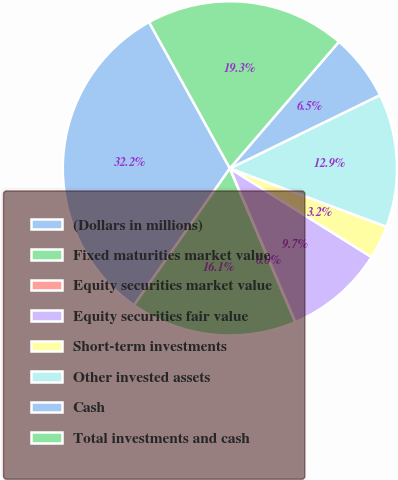Convert chart to OTSL. <chart><loc_0><loc_0><loc_500><loc_500><pie_chart><fcel>(Dollars in millions)<fcel>Fixed maturities market value<fcel>Equity securities market value<fcel>Equity securities fair value<fcel>Short-term investments<fcel>Other invested assets<fcel>Cash<fcel>Total investments and cash<nl><fcel>32.24%<fcel>16.13%<fcel>0.01%<fcel>9.68%<fcel>3.23%<fcel>12.9%<fcel>6.46%<fcel>19.35%<nl></chart> 